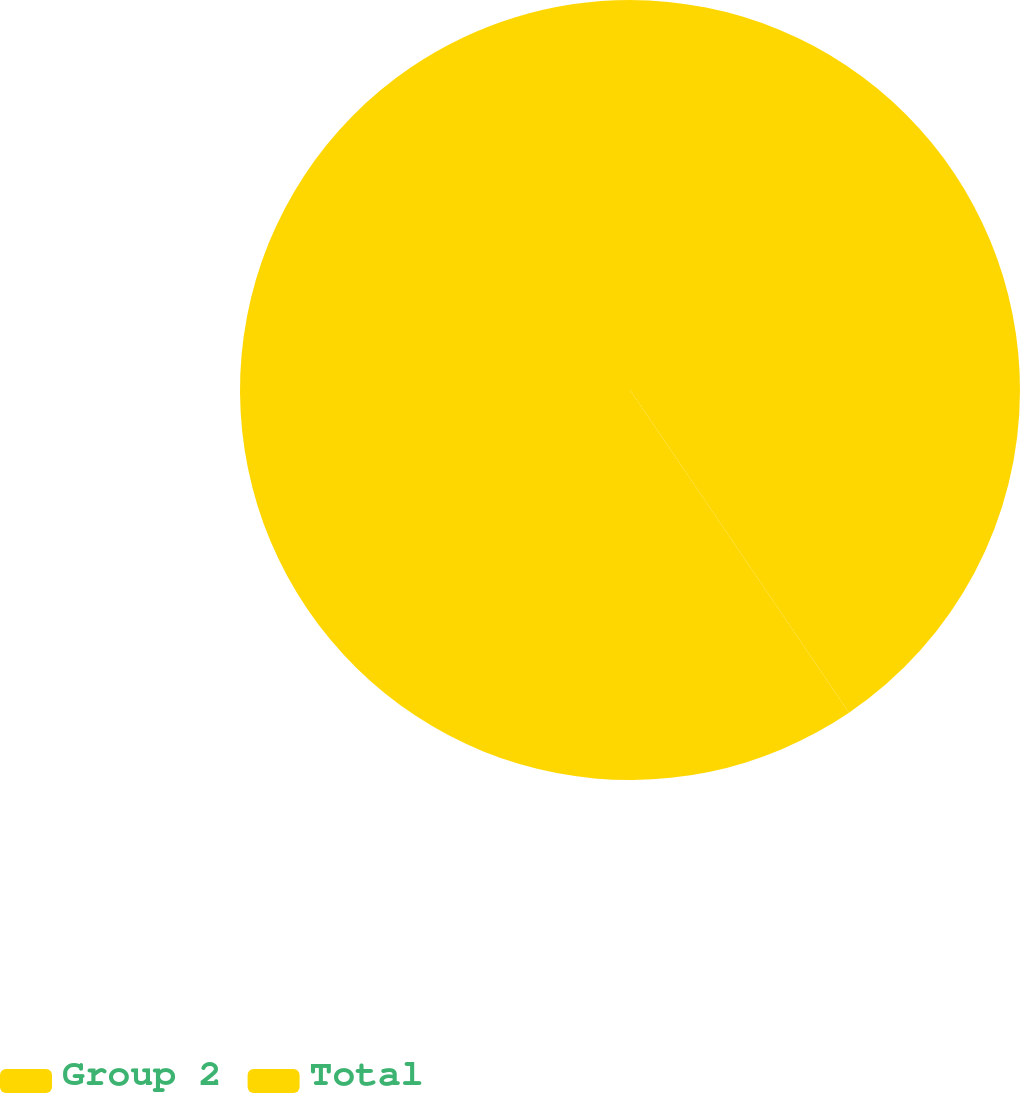Convert chart. <chart><loc_0><loc_0><loc_500><loc_500><pie_chart><fcel>Group 2<fcel>Total<nl><fcel>40.51%<fcel>59.49%<nl></chart> 